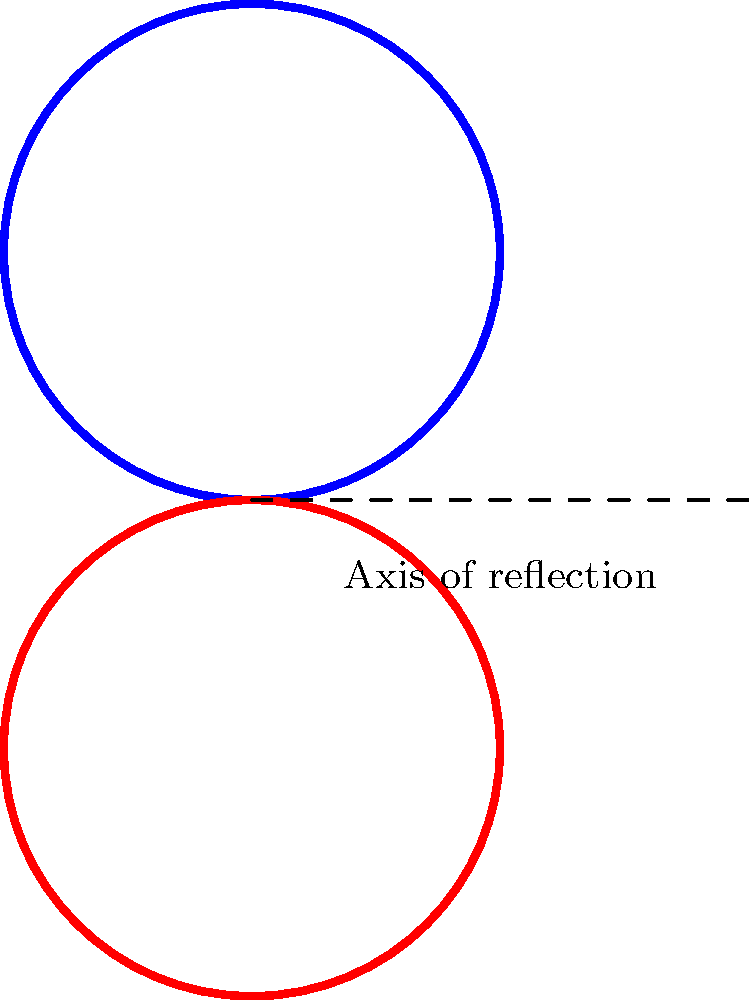In Celtic knot patterns, symmetry plays a crucial role. Consider the blue Celtic knot shown above. If we apply a reflection across the dashed line, we obtain the red knot. What is the order of the symmetry group for this combined pattern (blue and red knots together)? Let's approach this step-by-step:

1. First, we need to identify all the symmetries of the combined pattern:
   a) Identity (do nothing)
   b) Reflection across the dashed line

2. The reflection operation swaps the blue and red knots.

3. Applying the reflection twice brings us back to the original configuration.

4. There are no other symmetries (like rotations) that preserve the entire pattern.

5. In group theory, the order of a group is the number of elements in the group.

6. We have identified two symmetry operations: identity and reflection.

7. These two operations form a group under composition, known as the reflection group or $C_2$.

Therefore, the order of the symmetry group for this combined Celtic knot pattern is 2.
Answer: 2 